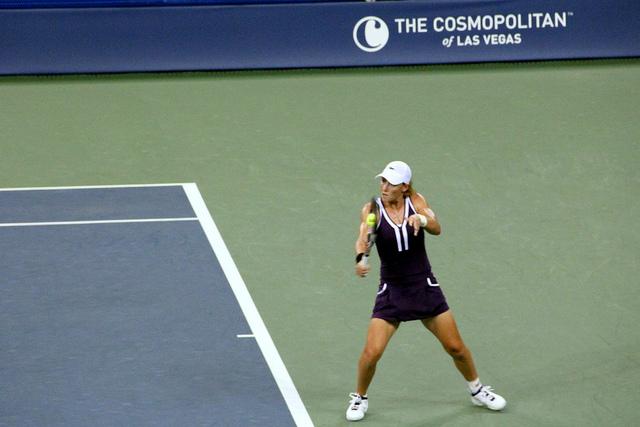What color is the girl's shirt?
Concise answer only. Black. Do you recognize this famous tennis player?
Concise answer only. No. Is there text in the top right corner of this picture?
Short answer required. Yes. Is this a tennis match in Brisbane?
Be succinct. No. How many people by the wall?
Keep it brief. 0. Is the player jumping?
Concise answer only. No. What brand of clothing is she wearing?
Concise answer only. Nike. 